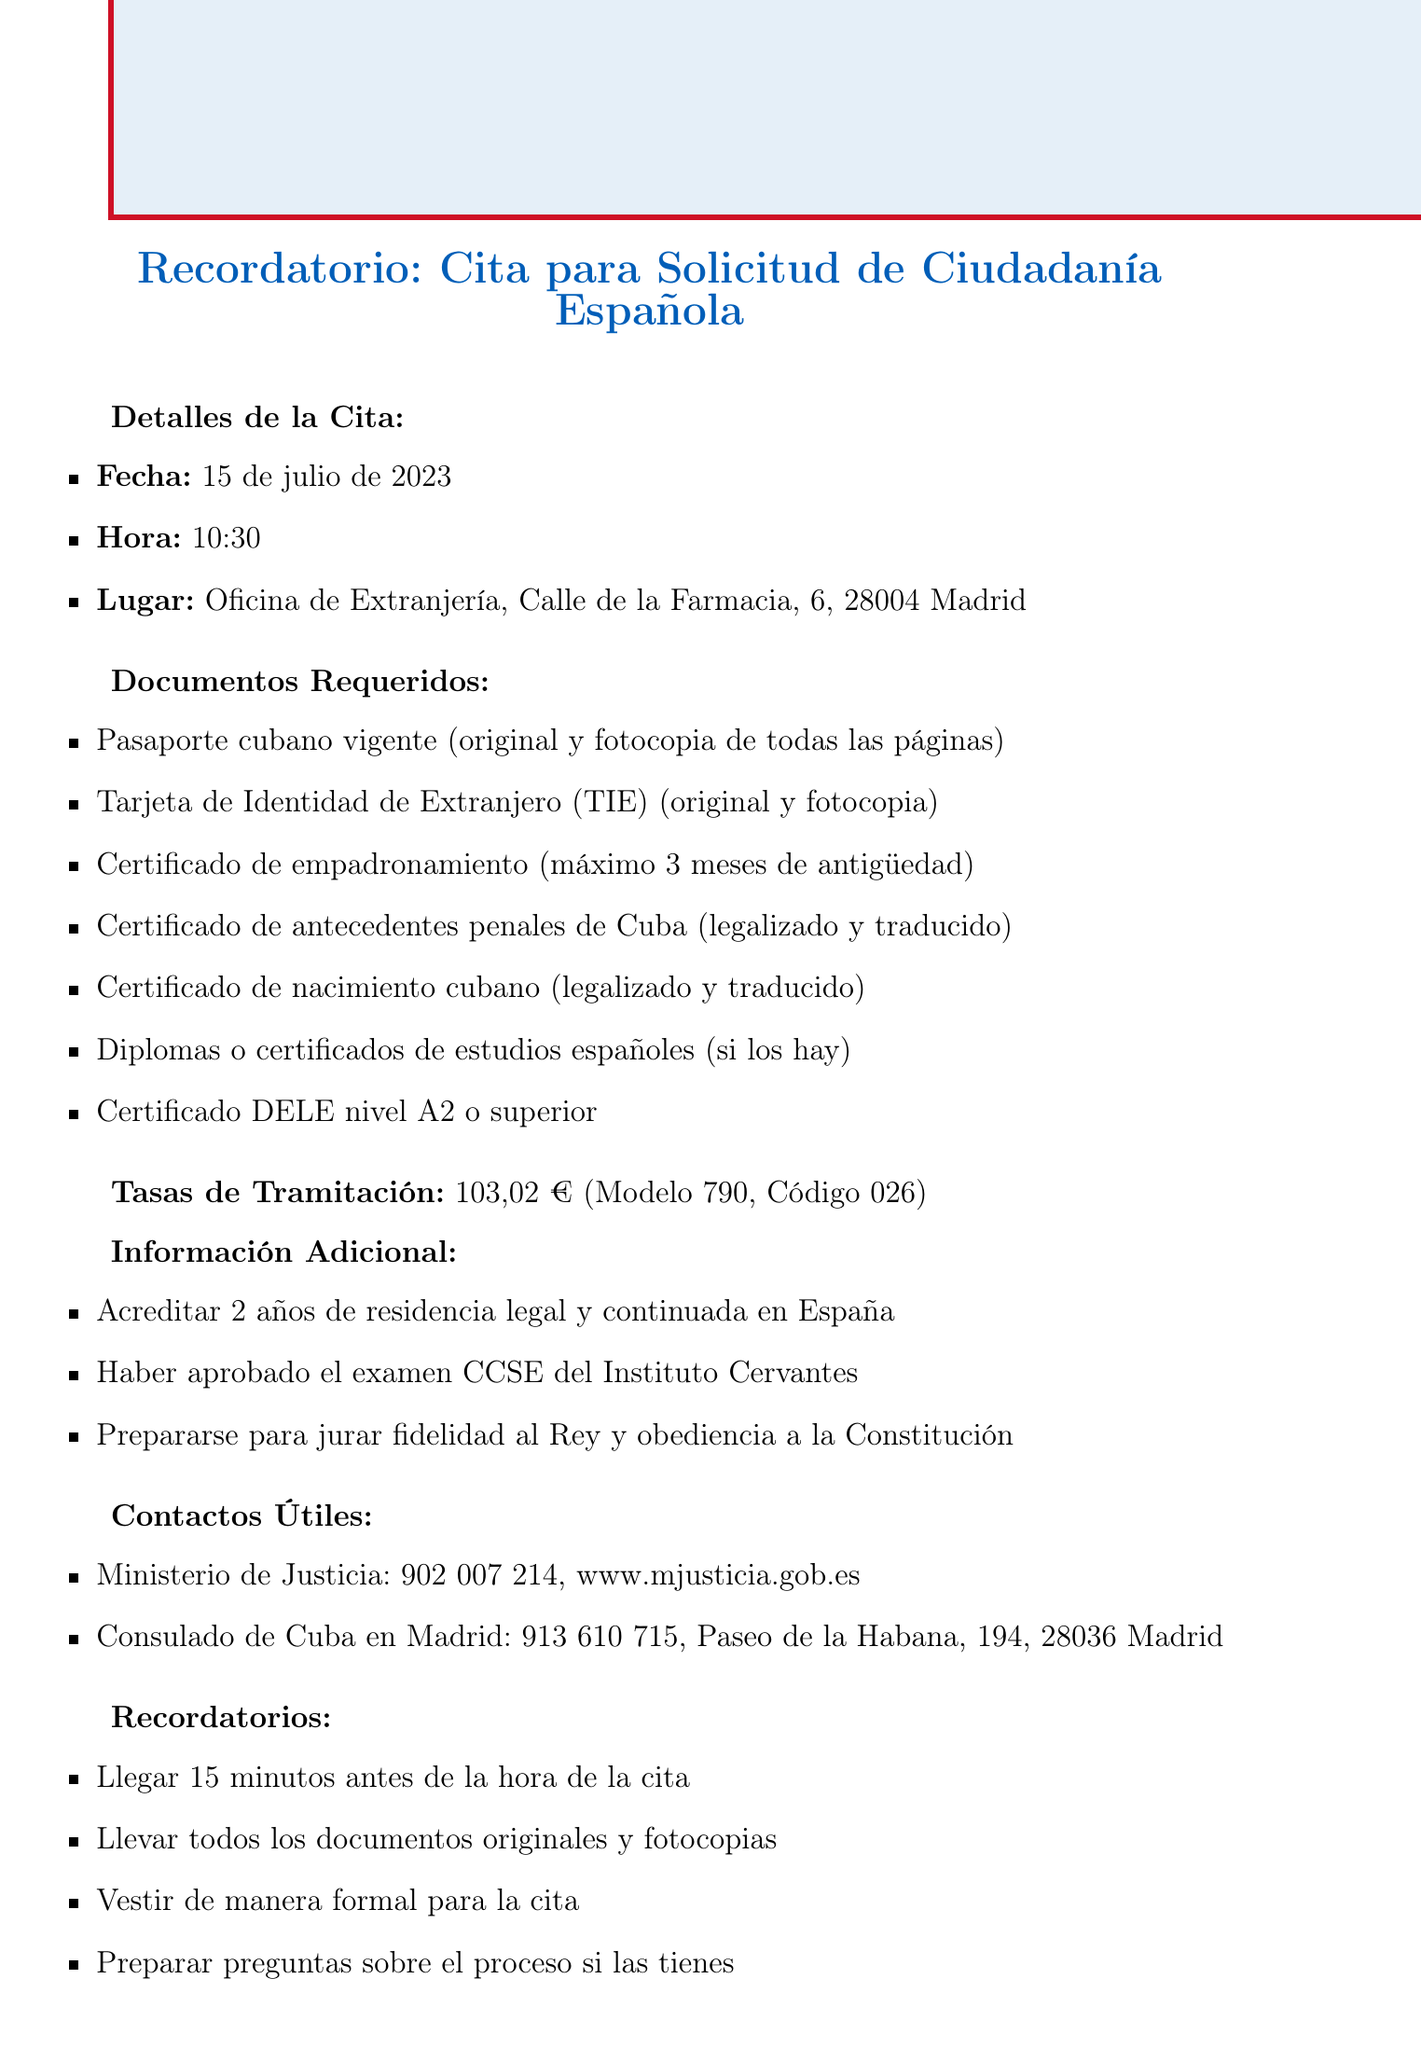¿Qué fecha es la cita para la solicitud de ciudadanía? La fecha se encuentra en la sección de detalles de la cita.
Answer: 15 de julio de 2023 ¿Cuál es el lugar de la cita? El lugar de la cita se detalla en la sección de detalles de la cita.
Answer: Oficina de Extranjería, Calle de la Farmacia, 6, 28004 Madrid ¿Qué documento se necesita para acreditar el conocimiento del idioma español? Este documento se menciona en la lista de documentos requeridos.
Answer: Certificado DELE nivel A2 o superior ¿Cuánto se debe pagar por la tramitación? La tasa de tramitación se indica en la sección de tasas de tramitación.
Answer: 103,02 € ¿Cuáles son los años de residencia requeridos para la solicitud? Esta información se encuentra en la sección de información adicional.
Answer: 2 años ¿Qué documento debe ser legalizado y traducido? La lista de documentos requeridos menciona este requisito.
Answer: Certificado de antecedentes penales de Cuba ¿Cuánto tiempo antes se debe llegar a la cita? Esta información está en la sección de recordatorios.
Answer: 15 minutos ¿A qué número se puede llamar para consultas sobre el proceso? Se encuentra en la sección de contactos útiles.
Answer: 902 007 214 